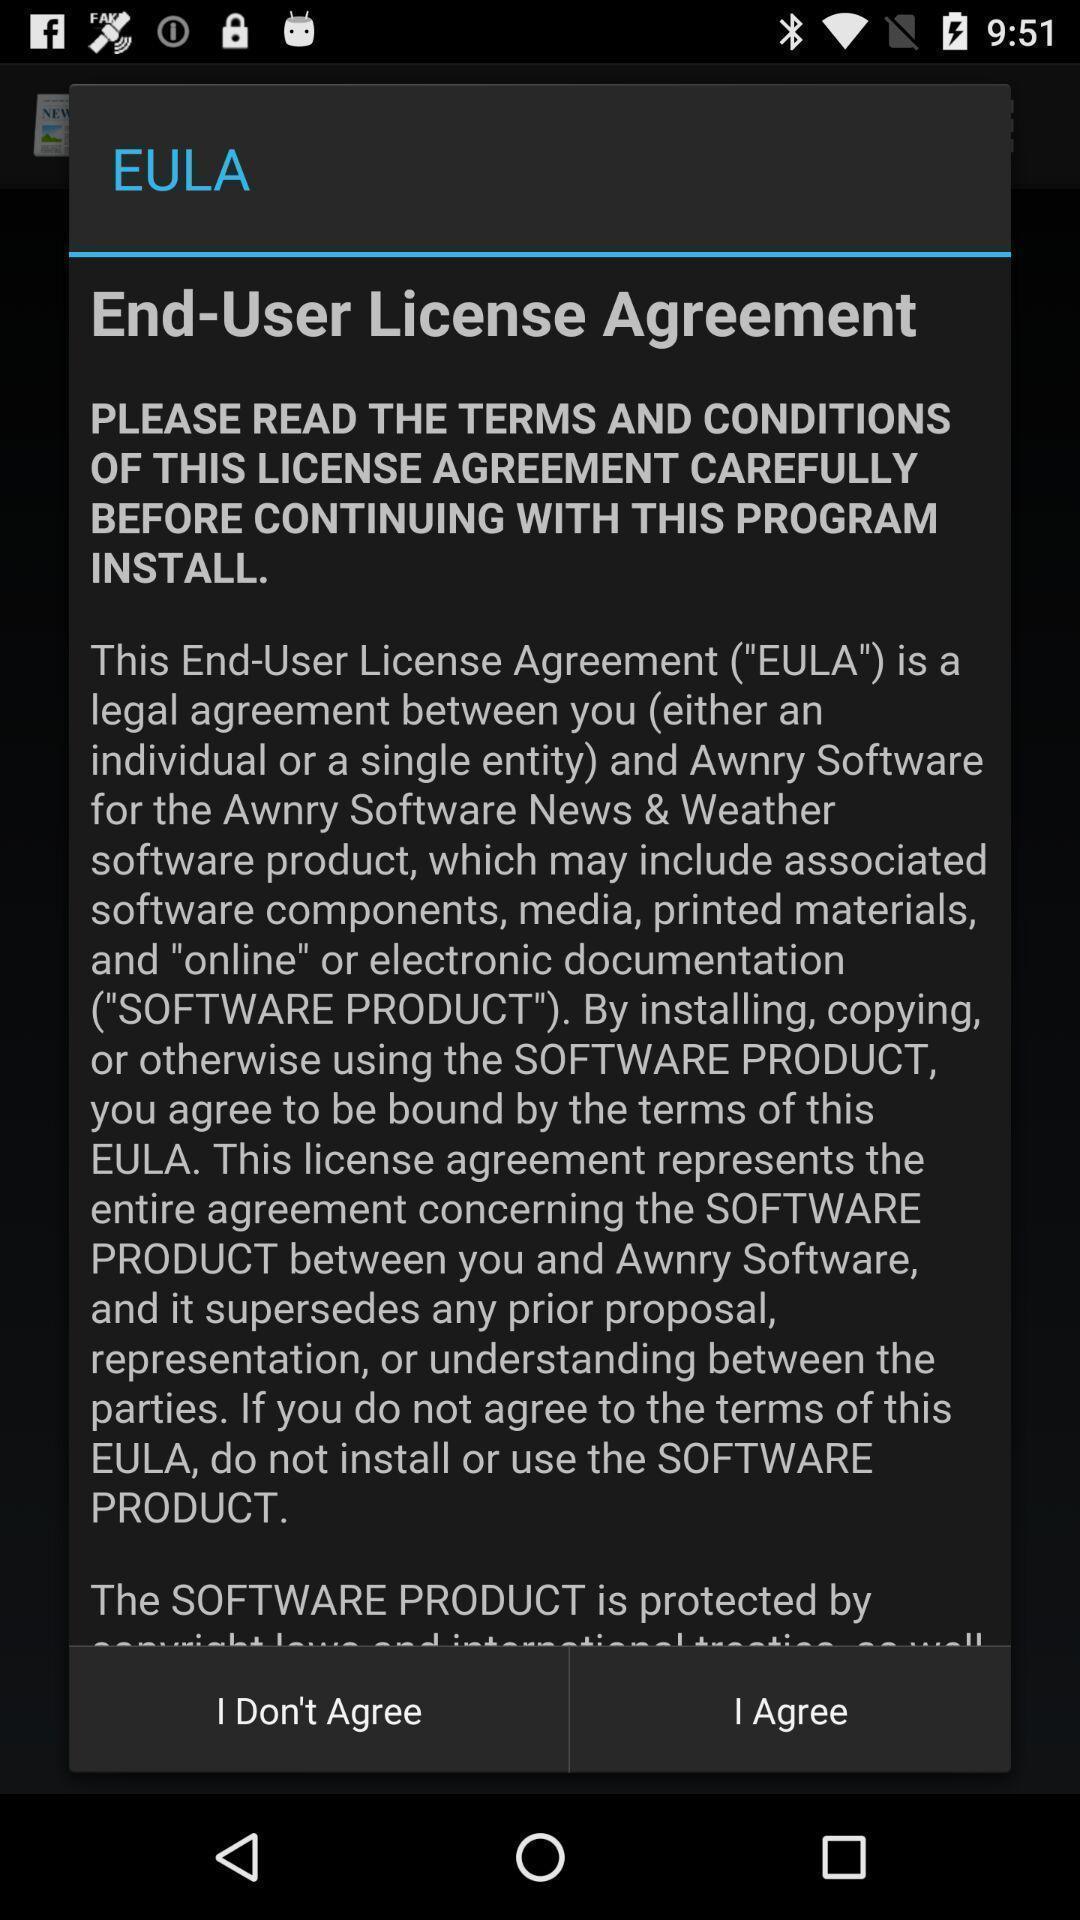What is the overall content of this screenshot? Popup of text regarding terms and conditions to agree. 